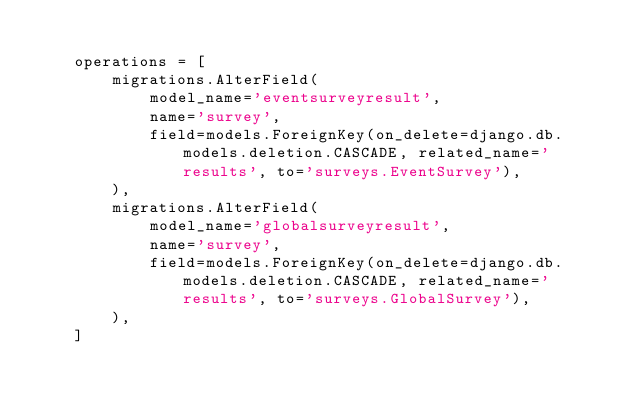Convert code to text. <code><loc_0><loc_0><loc_500><loc_500><_Python_>
    operations = [
        migrations.AlterField(
            model_name='eventsurveyresult',
            name='survey',
            field=models.ForeignKey(on_delete=django.db.models.deletion.CASCADE, related_name='results', to='surveys.EventSurvey'),
        ),
        migrations.AlterField(
            model_name='globalsurveyresult',
            name='survey',
            field=models.ForeignKey(on_delete=django.db.models.deletion.CASCADE, related_name='results', to='surveys.GlobalSurvey'),
        ),
    ]
</code> 